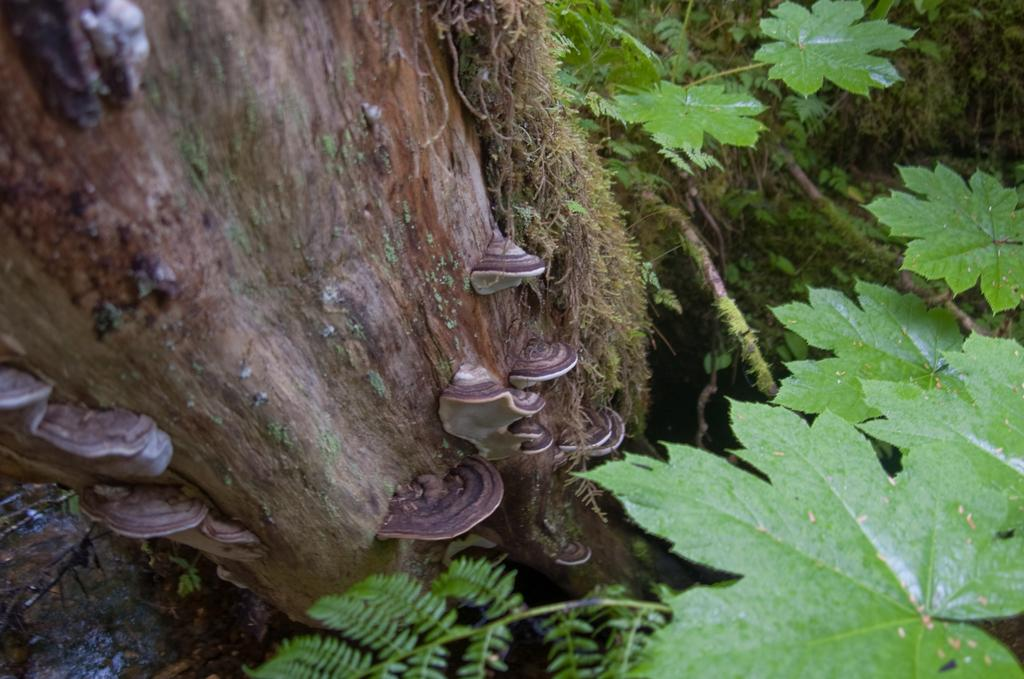What is the main subject in the middle of the image? There is a tree trunk in the middle of the image. What type of vegetation can be seen at the bottom of the image? There are green leaves at the bottom of the image. How many tickets are attached to the tree trunk in the image? There are no tickets present in the image; it only features a tree trunk and green leaves. 